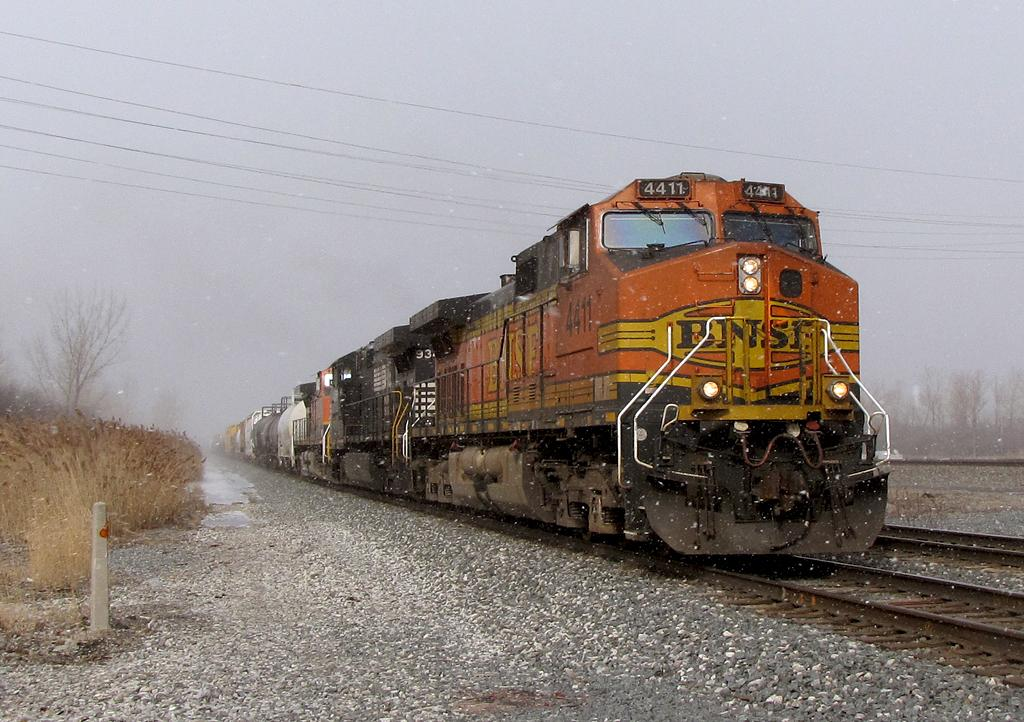What is the main subject of the image? The main subject of the image is a train. What is the train doing in the image? The train is moving on railway tracks. What can be seen on the right side of the train? Dry grass is present on the right side of the train. What is visible in the background of the image? The sky is visible in the image. What is the color of the sky in the image? The color of the sky is white. How does the train offer a ride to the cow in the image? There is no cow present in the image, so the train cannot offer a ride to a cow. 